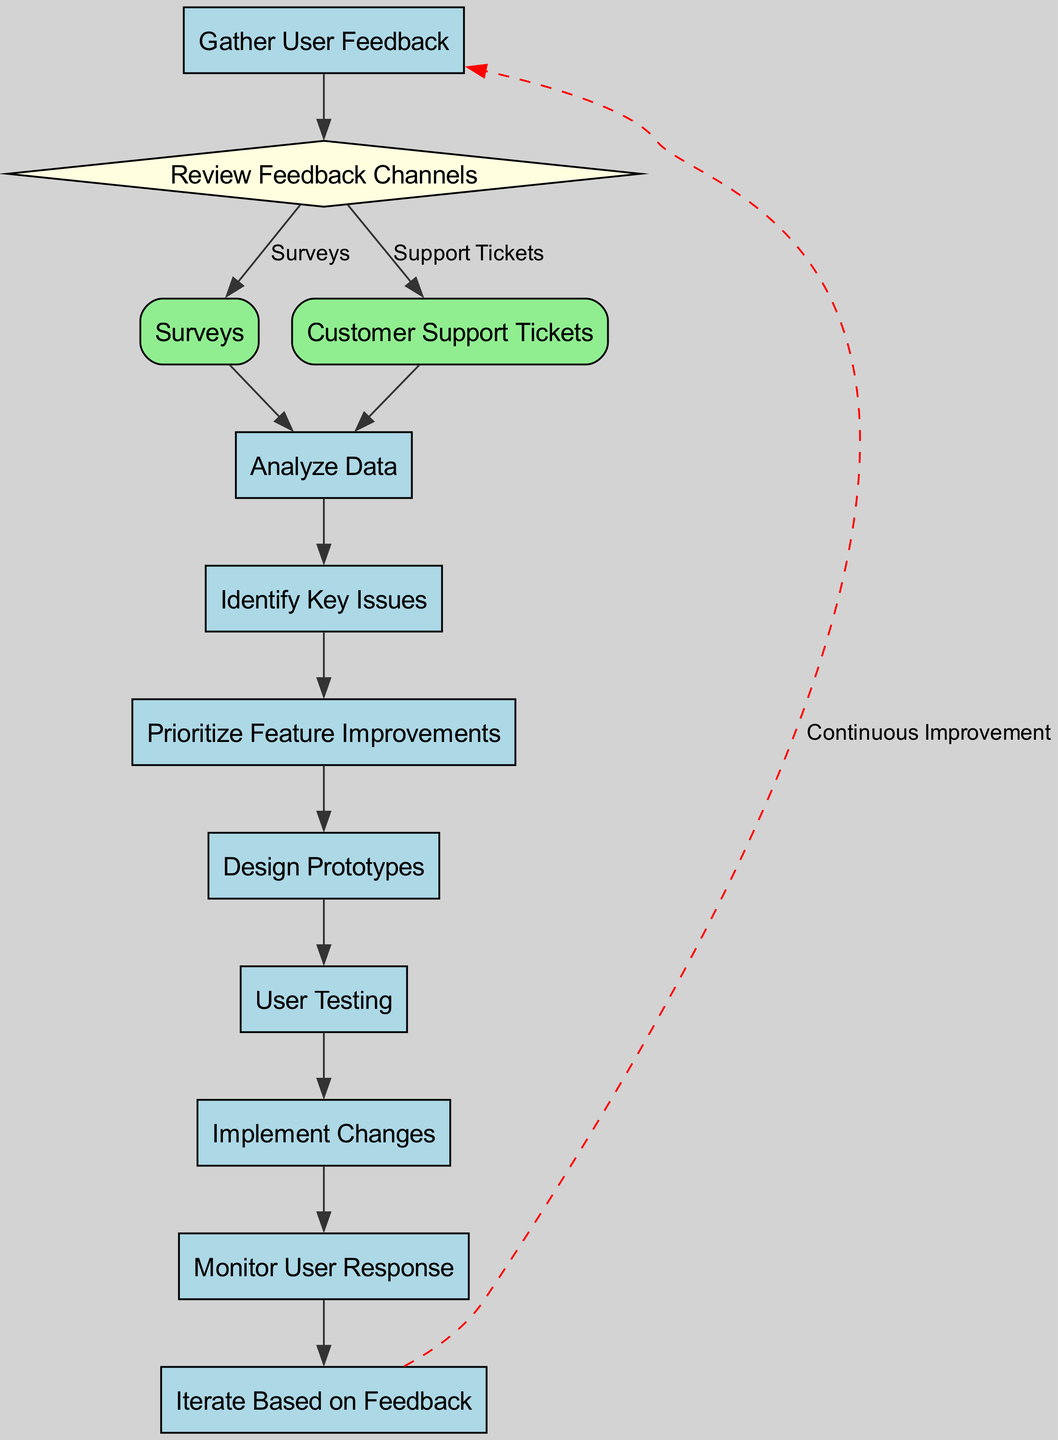What is the first step in the process? The first step in the flowchart is labeled "Gather User Feedback", which is the starting point. It leads to the next stage.
Answer: Gather User Feedback How many decision points are represented in the diagram? The flowchart contains a single decision point, identified as "Review Feedback Channels" which directs the flow to different sub-processes based on the feedback type.
Answer: 1 What are the two sub-processes derived from the decision point? The sub-processes linked to the decision point "Review Feedback Channels" are "Surveys" and "Customer Support Tickets". These represent the two ways feedback is collected.
Answer: Surveys, Customer Support Tickets What comes after "Analyze Data"? Following "Analyze Data", the next step in the process is "Identify Key Issues", indicating that after data analysis, issues are determined.
Answer: Identify Key Issues Which step follows "User Testing"? After "User Testing", the subsequent step taken is "Implement Changes", showing that after testing, changes are to be implemented based on user feedback.
Answer: Implement Changes What indicates the process is continuous? The flowchart shows "Iterate Based on Feedback" as connecting back to "Gather User Feedback" with a dashed red line, signifying the ongoing nature of the feedback loop in the design process.
Answer: Continuous Improvement What is the last step before implementing changes? Before implementing changes, the last step is "User Testing", which ensures that changes are validated through direct user interaction before full implementation.
Answer: User Testing How many total processes are in the diagram? The diagram includes multiple processes, specifically 6 main processes: "Gather User Feedback", "Analyze Data", "Identify Key Issues", "Prioritize Feature Improvements", "Design Prototypes", and "Monitor User Response".
Answer: 6 